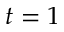Convert formula to latex. <formula><loc_0><loc_0><loc_500><loc_500>t = 1</formula> 